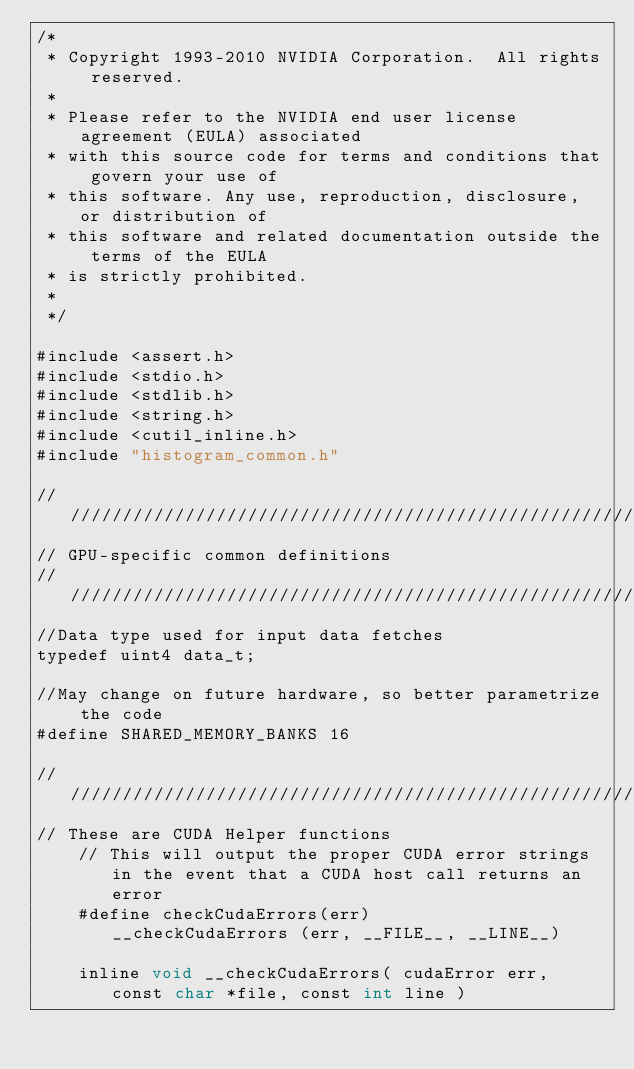<code> <loc_0><loc_0><loc_500><loc_500><_Cuda_>/*
 * Copyright 1993-2010 NVIDIA Corporation.  All rights reserved.
 *
 * Please refer to the NVIDIA end user license agreement (EULA) associated
 * with this source code for terms and conditions that govern your use of
 * this software. Any use, reproduction, disclosure, or distribution of
 * this software and related documentation outside the terms of the EULA
 * is strictly prohibited.
 *
 */

#include <assert.h>
#include <stdio.h>
#include <stdlib.h>
#include <string.h>
#include <cutil_inline.h>
#include "histogram_common.h"

////////////////////////////////////////////////////////////////////////////////
// GPU-specific common definitions
////////////////////////////////////////////////////////////////////////////////
//Data type used for input data fetches
typedef uint4 data_t;

//May change on future hardware, so better parametrize the code
#define SHARED_MEMORY_BANKS 16

////////////////////////////////////////////////////////////////////////////////
// These are CUDA Helper functions
    // This will output the proper CUDA error strings in the event that a CUDA host call returns an error
    #define checkCudaErrors(err)           __checkCudaErrors (err, __FILE__, __LINE__)

    inline void __checkCudaErrors( cudaError err, const char *file, const int line )</code> 